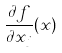<formula> <loc_0><loc_0><loc_500><loc_500>\frac { \partial f } { \partial x _ { j } } ( x )</formula> 